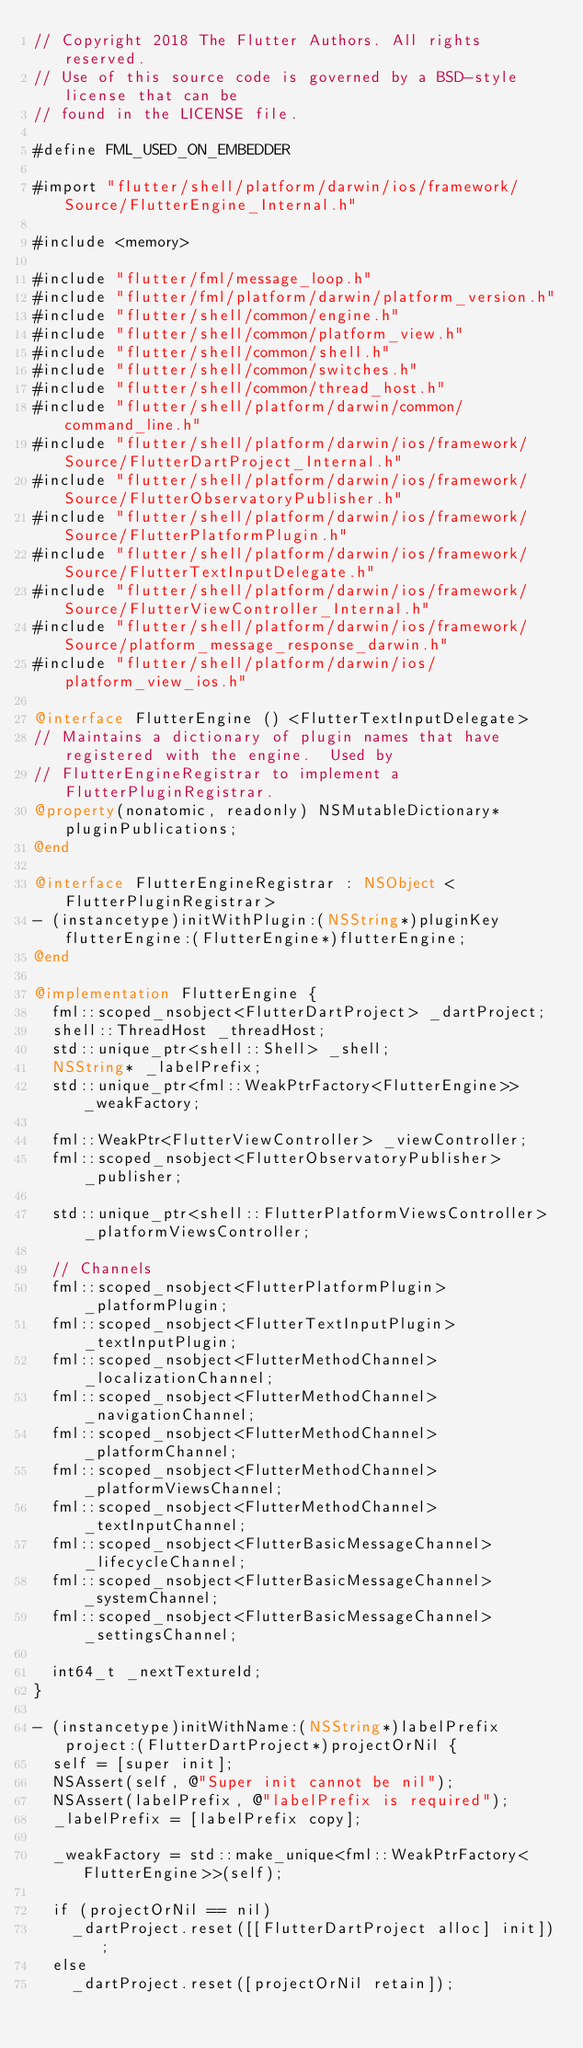Convert code to text. <code><loc_0><loc_0><loc_500><loc_500><_ObjectiveC_>// Copyright 2018 The Flutter Authors. All rights reserved.
// Use of this source code is governed by a BSD-style license that can be
// found in the LICENSE file.

#define FML_USED_ON_EMBEDDER

#import "flutter/shell/platform/darwin/ios/framework/Source/FlutterEngine_Internal.h"

#include <memory>

#include "flutter/fml/message_loop.h"
#include "flutter/fml/platform/darwin/platform_version.h"
#include "flutter/shell/common/engine.h"
#include "flutter/shell/common/platform_view.h"
#include "flutter/shell/common/shell.h"
#include "flutter/shell/common/switches.h"
#include "flutter/shell/common/thread_host.h"
#include "flutter/shell/platform/darwin/common/command_line.h"
#include "flutter/shell/platform/darwin/ios/framework/Source/FlutterDartProject_Internal.h"
#include "flutter/shell/platform/darwin/ios/framework/Source/FlutterObservatoryPublisher.h"
#include "flutter/shell/platform/darwin/ios/framework/Source/FlutterPlatformPlugin.h"
#include "flutter/shell/platform/darwin/ios/framework/Source/FlutterTextInputDelegate.h"
#include "flutter/shell/platform/darwin/ios/framework/Source/FlutterViewController_Internal.h"
#include "flutter/shell/platform/darwin/ios/framework/Source/platform_message_response_darwin.h"
#include "flutter/shell/platform/darwin/ios/platform_view_ios.h"

@interface FlutterEngine () <FlutterTextInputDelegate>
// Maintains a dictionary of plugin names that have registered with the engine.  Used by
// FlutterEngineRegistrar to implement a FlutterPluginRegistrar.
@property(nonatomic, readonly) NSMutableDictionary* pluginPublications;
@end

@interface FlutterEngineRegistrar : NSObject <FlutterPluginRegistrar>
- (instancetype)initWithPlugin:(NSString*)pluginKey flutterEngine:(FlutterEngine*)flutterEngine;
@end

@implementation FlutterEngine {
  fml::scoped_nsobject<FlutterDartProject> _dartProject;
  shell::ThreadHost _threadHost;
  std::unique_ptr<shell::Shell> _shell;
  NSString* _labelPrefix;
  std::unique_ptr<fml::WeakPtrFactory<FlutterEngine>> _weakFactory;

  fml::WeakPtr<FlutterViewController> _viewController;
  fml::scoped_nsobject<FlutterObservatoryPublisher> _publisher;

  std::unique_ptr<shell::FlutterPlatformViewsController> _platformViewsController;

  // Channels
  fml::scoped_nsobject<FlutterPlatformPlugin> _platformPlugin;
  fml::scoped_nsobject<FlutterTextInputPlugin> _textInputPlugin;
  fml::scoped_nsobject<FlutterMethodChannel> _localizationChannel;
  fml::scoped_nsobject<FlutterMethodChannel> _navigationChannel;
  fml::scoped_nsobject<FlutterMethodChannel> _platformChannel;
  fml::scoped_nsobject<FlutterMethodChannel> _platformViewsChannel;
  fml::scoped_nsobject<FlutterMethodChannel> _textInputChannel;
  fml::scoped_nsobject<FlutterBasicMessageChannel> _lifecycleChannel;
  fml::scoped_nsobject<FlutterBasicMessageChannel> _systemChannel;
  fml::scoped_nsobject<FlutterBasicMessageChannel> _settingsChannel;

  int64_t _nextTextureId;
}

- (instancetype)initWithName:(NSString*)labelPrefix project:(FlutterDartProject*)projectOrNil {
  self = [super init];
  NSAssert(self, @"Super init cannot be nil");
  NSAssert(labelPrefix, @"labelPrefix is required");
  _labelPrefix = [labelPrefix copy];

  _weakFactory = std::make_unique<fml::WeakPtrFactory<FlutterEngine>>(self);

  if (projectOrNil == nil)
    _dartProject.reset([[FlutterDartProject alloc] init]);
  else
    _dartProject.reset([projectOrNil retain]);
</code> 